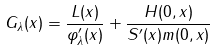<formula> <loc_0><loc_0><loc_500><loc_500>G _ { \lambda } ( x ) = \frac { L ( x ) } { \varphi _ { \lambda } ^ { \prime } ( x ) } + \frac { H ( 0 , x ) } { S ^ { \prime } ( x ) m ( 0 , x ) }</formula> 